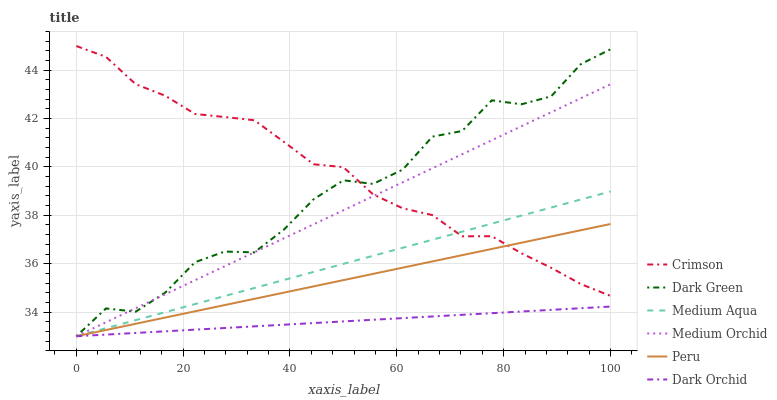Does Dark Orchid have the minimum area under the curve?
Answer yes or no. Yes. Does Crimson have the maximum area under the curve?
Answer yes or no. Yes. Does Medium Aqua have the minimum area under the curve?
Answer yes or no. No. Does Medium Aqua have the maximum area under the curve?
Answer yes or no. No. Is Medium Aqua the smoothest?
Answer yes or no. Yes. Is Dark Green the roughest?
Answer yes or no. Yes. Is Dark Orchid the smoothest?
Answer yes or no. No. Is Dark Orchid the roughest?
Answer yes or no. No. Does Medium Orchid have the lowest value?
Answer yes or no. Yes. Does Crimson have the lowest value?
Answer yes or no. No. Does Crimson have the highest value?
Answer yes or no. Yes. Does Medium Aqua have the highest value?
Answer yes or no. No. Is Dark Orchid less than Crimson?
Answer yes or no. Yes. Is Crimson greater than Dark Orchid?
Answer yes or no. Yes. Does Peru intersect Medium Orchid?
Answer yes or no. Yes. Is Peru less than Medium Orchid?
Answer yes or no. No. Is Peru greater than Medium Orchid?
Answer yes or no. No. Does Dark Orchid intersect Crimson?
Answer yes or no. No. 